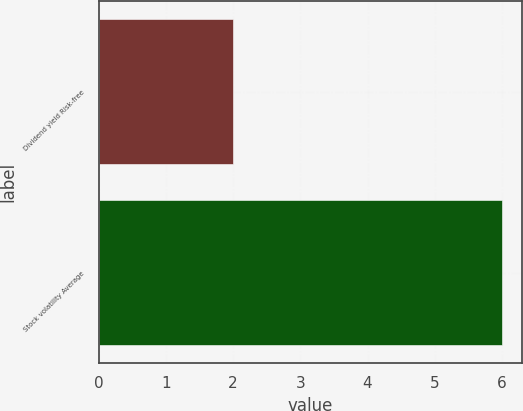Convert chart to OTSL. <chart><loc_0><loc_0><loc_500><loc_500><bar_chart><fcel>Dividend yield Risk-free<fcel>Stock volatility Average<nl><fcel>2<fcel>6<nl></chart> 